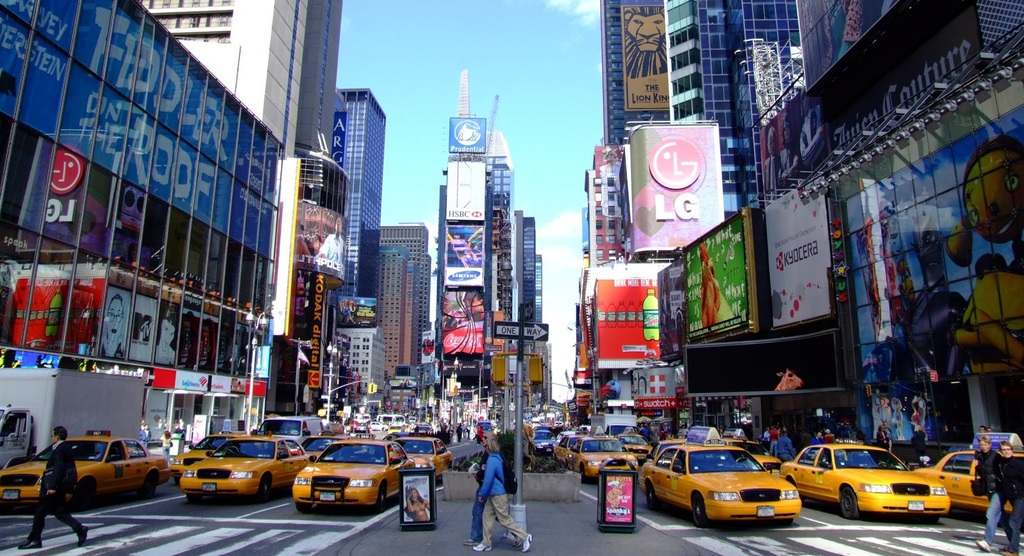Describe the overall mood or atmosphere captured in this image of a busy city intersection. The image radiates a lively and dynamic atmosphere typical of an urban environment, highlighted by the bustling traffic and colorful, towering advertisements that convey a sense of constant movement and commercial activity. 